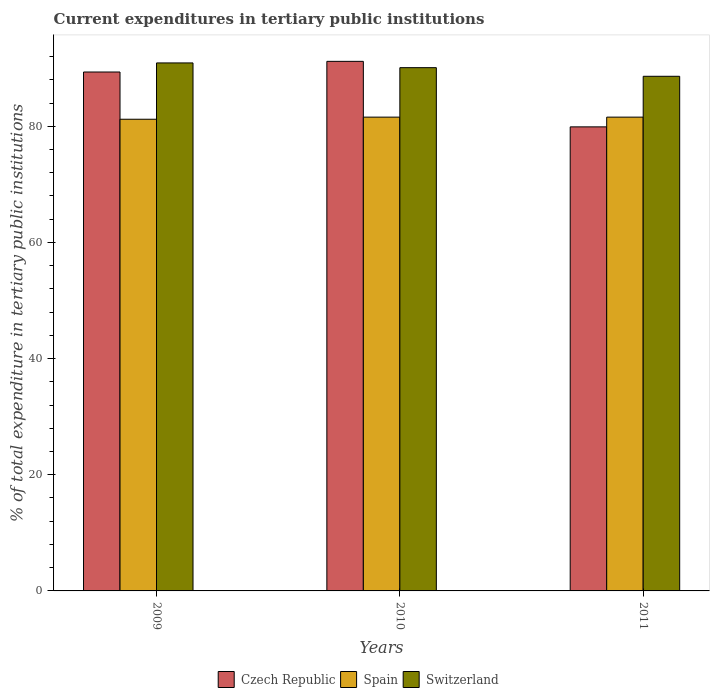Are the number of bars per tick equal to the number of legend labels?
Provide a short and direct response. Yes. Are the number of bars on each tick of the X-axis equal?
Offer a very short reply. Yes. What is the label of the 2nd group of bars from the left?
Keep it short and to the point. 2010. What is the current expenditures in tertiary public institutions in Czech Republic in 2009?
Provide a short and direct response. 89.35. Across all years, what is the maximum current expenditures in tertiary public institutions in Spain?
Keep it short and to the point. 81.58. Across all years, what is the minimum current expenditures in tertiary public institutions in Switzerland?
Ensure brevity in your answer.  88.61. In which year was the current expenditures in tertiary public institutions in Czech Republic minimum?
Keep it short and to the point. 2011. What is the total current expenditures in tertiary public institutions in Spain in the graph?
Provide a short and direct response. 244.38. What is the difference between the current expenditures in tertiary public institutions in Switzerland in 2009 and that in 2011?
Your response must be concise. 2.3. What is the difference between the current expenditures in tertiary public institutions in Spain in 2011 and the current expenditures in tertiary public institutions in Czech Republic in 2010?
Keep it short and to the point. -9.6. What is the average current expenditures in tertiary public institutions in Spain per year?
Provide a succinct answer. 81.46. In the year 2011, what is the difference between the current expenditures in tertiary public institutions in Czech Republic and current expenditures in tertiary public institutions in Spain?
Offer a very short reply. -1.68. In how many years, is the current expenditures in tertiary public institutions in Spain greater than 44 %?
Offer a terse response. 3. What is the ratio of the current expenditures in tertiary public institutions in Spain in 2009 to that in 2010?
Your answer should be very brief. 1. Is the current expenditures in tertiary public institutions in Czech Republic in 2009 less than that in 2010?
Offer a terse response. Yes. Is the difference between the current expenditures in tertiary public institutions in Czech Republic in 2009 and 2010 greater than the difference between the current expenditures in tertiary public institutions in Spain in 2009 and 2010?
Make the answer very short. No. What is the difference between the highest and the second highest current expenditures in tertiary public institutions in Switzerland?
Give a very brief answer. 0.82. What is the difference between the highest and the lowest current expenditures in tertiary public institutions in Czech Republic?
Your answer should be very brief. 11.28. In how many years, is the current expenditures in tertiary public institutions in Czech Republic greater than the average current expenditures in tertiary public institutions in Czech Republic taken over all years?
Provide a succinct answer. 2. Is the sum of the current expenditures in tertiary public institutions in Spain in 2010 and 2011 greater than the maximum current expenditures in tertiary public institutions in Switzerland across all years?
Give a very brief answer. Yes. What does the 1st bar from the left in 2010 represents?
Your response must be concise. Czech Republic. How many bars are there?
Ensure brevity in your answer.  9. Are all the bars in the graph horizontal?
Provide a succinct answer. No. What is the difference between two consecutive major ticks on the Y-axis?
Keep it short and to the point. 20. Where does the legend appear in the graph?
Give a very brief answer. Bottom center. How many legend labels are there?
Keep it short and to the point. 3. How are the legend labels stacked?
Give a very brief answer. Horizontal. What is the title of the graph?
Give a very brief answer. Current expenditures in tertiary public institutions. Does "Uruguay" appear as one of the legend labels in the graph?
Your answer should be very brief. No. What is the label or title of the X-axis?
Your response must be concise. Years. What is the label or title of the Y-axis?
Make the answer very short. % of total expenditure in tertiary public institutions. What is the % of total expenditure in tertiary public institutions of Czech Republic in 2009?
Provide a short and direct response. 89.35. What is the % of total expenditure in tertiary public institutions of Spain in 2009?
Make the answer very short. 81.22. What is the % of total expenditure in tertiary public institutions of Switzerland in 2009?
Ensure brevity in your answer.  90.91. What is the % of total expenditure in tertiary public institutions in Czech Republic in 2010?
Your answer should be compact. 91.18. What is the % of total expenditure in tertiary public institutions in Spain in 2010?
Offer a terse response. 81.58. What is the % of total expenditure in tertiary public institutions of Switzerland in 2010?
Make the answer very short. 90.1. What is the % of total expenditure in tertiary public institutions of Czech Republic in 2011?
Give a very brief answer. 79.9. What is the % of total expenditure in tertiary public institutions in Spain in 2011?
Give a very brief answer. 81.58. What is the % of total expenditure in tertiary public institutions in Switzerland in 2011?
Provide a short and direct response. 88.61. Across all years, what is the maximum % of total expenditure in tertiary public institutions of Czech Republic?
Your answer should be very brief. 91.18. Across all years, what is the maximum % of total expenditure in tertiary public institutions of Spain?
Keep it short and to the point. 81.58. Across all years, what is the maximum % of total expenditure in tertiary public institutions in Switzerland?
Give a very brief answer. 90.91. Across all years, what is the minimum % of total expenditure in tertiary public institutions of Czech Republic?
Make the answer very short. 79.9. Across all years, what is the minimum % of total expenditure in tertiary public institutions in Spain?
Your response must be concise. 81.22. Across all years, what is the minimum % of total expenditure in tertiary public institutions of Switzerland?
Your response must be concise. 88.61. What is the total % of total expenditure in tertiary public institutions in Czech Republic in the graph?
Provide a succinct answer. 260.43. What is the total % of total expenditure in tertiary public institutions of Spain in the graph?
Your answer should be compact. 244.38. What is the total % of total expenditure in tertiary public institutions in Switzerland in the graph?
Ensure brevity in your answer.  269.62. What is the difference between the % of total expenditure in tertiary public institutions of Czech Republic in 2009 and that in 2010?
Give a very brief answer. -1.84. What is the difference between the % of total expenditure in tertiary public institutions in Spain in 2009 and that in 2010?
Offer a very short reply. -0.36. What is the difference between the % of total expenditure in tertiary public institutions in Switzerland in 2009 and that in 2010?
Offer a terse response. 0.82. What is the difference between the % of total expenditure in tertiary public institutions in Czech Republic in 2009 and that in 2011?
Offer a terse response. 9.45. What is the difference between the % of total expenditure in tertiary public institutions in Spain in 2009 and that in 2011?
Your answer should be very brief. -0.36. What is the difference between the % of total expenditure in tertiary public institutions of Switzerland in 2009 and that in 2011?
Your answer should be compact. 2.3. What is the difference between the % of total expenditure in tertiary public institutions of Czech Republic in 2010 and that in 2011?
Ensure brevity in your answer.  11.28. What is the difference between the % of total expenditure in tertiary public institutions in Spain in 2010 and that in 2011?
Make the answer very short. 0. What is the difference between the % of total expenditure in tertiary public institutions of Switzerland in 2010 and that in 2011?
Give a very brief answer. 1.48. What is the difference between the % of total expenditure in tertiary public institutions in Czech Republic in 2009 and the % of total expenditure in tertiary public institutions in Spain in 2010?
Your answer should be very brief. 7.77. What is the difference between the % of total expenditure in tertiary public institutions of Czech Republic in 2009 and the % of total expenditure in tertiary public institutions of Switzerland in 2010?
Your answer should be very brief. -0.75. What is the difference between the % of total expenditure in tertiary public institutions of Spain in 2009 and the % of total expenditure in tertiary public institutions of Switzerland in 2010?
Offer a terse response. -8.88. What is the difference between the % of total expenditure in tertiary public institutions of Czech Republic in 2009 and the % of total expenditure in tertiary public institutions of Spain in 2011?
Keep it short and to the point. 7.77. What is the difference between the % of total expenditure in tertiary public institutions in Czech Republic in 2009 and the % of total expenditure in tertiary public institutions in Switzerland in 2011?
Your answer should be compact. 0.74. What is the difference between the % of total expenditure in tertiary public institutions in Spain in 2009 and the % of total expenditure in tertiary public institutions in Switzerland in 2011?
Make the answer very short. -7.4. What is the difference between the % of total expenditure in tertiary public institutions of Czech Republic in 2010 and the % of total expenditure in tertiary public institutions of Spain in 2011?
Keep it short and to the point. 9.6. What is the difference between the % of total expenditure in tertiary public institutions of Czech Republic in 2010 and the % of total expenditure in tertiary public institutions of Switzerland in 2011?
Ensure brevity in your answer.  2.57. What is the difference between the % of total expenditure in tertiary public institutions in Spain in 2010 and the % of total expenditure in tertiary public institutions in Switzerland in 2011?
Give a very brief answer. -7.03. What is the average % of total expenditure in tertiary public institutions of Czech Republic per year?
Provide a succinct answer. 86.81. What is the average % of total expenditure in tertiary public institutions in Spain per year?
Ensure brevity in your answer.  81.46. What is the average % of total expenditure in tertiary public institutions in Switzerland per year?
Offer a terse response. 89.87. In the year 2009, what is the difference between the % of total expenditure in tertiary public institutions in Czech Republic and % of total expenditure in tertiary public institutions in Spain?
Your response must be concise. 8.13. In the year 2009, what is the difference between the % of total expenditure in tertiary public institutions in Czech Republic and % of total expenditure in tertiary public institutions in Switzerland?
Your response must be concise. -1.56. In the year 2009, what is the difference between the % of total expenditure in tertiary public institutions of Spain and % of total expenditure in tertiary public institutions of Switzerland?
Ensure brevity in your answer.  -9.7. In the year 2010, what is the difference between the % of total expenditure in tertiary public institutions of Czech Republic and % of total expenditure in tertiary public institutions of Spain?
Your answer should be compact. 9.6. In the year 2010, what is the difference between the % of total expenditure in tertiary public institutions of Czech Republic and % of total expenditure in tertiary public institutions of Switzerland?
Keep it short and to the point. 1.09. In the year 2010, what is the difference between the % of total expenditure in tertiary public institutions of Spain and % of total expenditure in tertiary public institutions of Switzerland?
Offer a very short reply. -8.52. In the year 2011, what is the difference between the % of total expenditure in tertiary public institutions in Czech Republic and % of total expenditure in tertiary public institutions in Spain?
Give a very brief answer. -1.68. In the year 2011, what is the difference between the % of total expenditure in tertiary public institutions in Czech Republic and % of total expenditure in tertiary public institutions in Switzerland?
Offer a terse response. -8.71. In the year 2011, what is the difference between the % of total expenditure in tertiary public institutions in Spain and % of total expenditure in tertiary public institutions in Switzerland?
Your response must be concise. -7.03. What is the ratio of the % of total expenditure in tertiary public institutions of Czech Republic in 2009 to that in 2010?
Give a very brief answer. 0.98. What is the ratio of the % of total expenditure in tertiary public institutions in Switzerland in 2009 to that in 2010?
Your answer should be compact. 1.01. What is the ratio of the % of total expenditure in tertiary public institutions in Czech Republic in 2009 to that in 2011?
Your answer should be compact. 1.12. What is the ratio of the % of total expenditure in tertiary public institutions in Czech Republic in 2010 to that in 2011?
Your answer should be very brief. 1.14. What is the ratio of the % of total expenditure in tertiary public institutions of Switzerland in 2010 to that in 2011?
Your answer should be very brief. 1.02. What is the difference between the highest and the second highest % of total expenditure in tertiary public institutions of Czech Republic?
Ensure brevity in your answer.  1.84. What is the difference between the highest and the second highest % of total expenditure in tertiary public institutions of Switzerland?
Ensure brevity in your answer.  0.82. What is the difference between the highest and the lowest % of total expenditure in tertiary public institutions in Czech Republic?
Offer a terse response. 11.28. What is the difference between the highest and the lowest % of total expenditure in tertiary public institutions of Spain?
Keep it short and to the point. 0.36. What is the difference between the highest and the lowest % of total expenditure in tertiary public institutions of Switzerland?
Give a very brief answer. 2.3. 